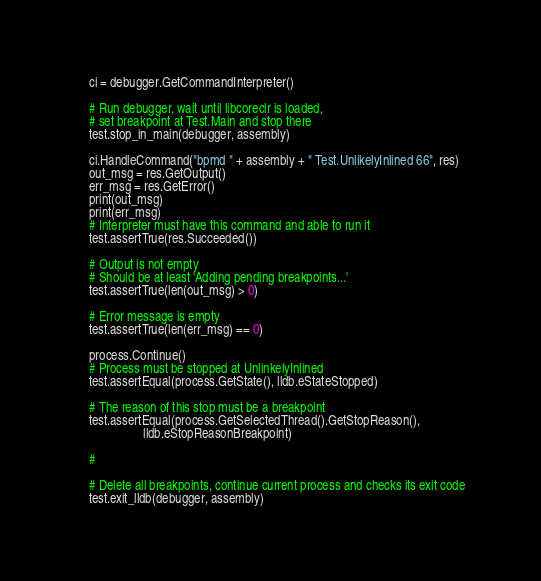<code> <loc_0><loc_0><loc_500><loc_500><_Python_>    ci = debugger.GetCommandInterpreter()

    # Run debugger, wait until libcoreclr is loaded,
    # set breakpoint at Test.Main and stop there
    test.stop_in_main(debugger, assembly)

    ci.HandleCommand("bpmd " + assembly + " Test.UnlikelyInlined 66", res)
    out_msg = res.GetOutput()
    err_msg = res.GetError()
    print(out_msg)
    print(err_msg)
    # Interpreter must have this command and able to run it
    test.assertTrue(res.Succeeded())

    # Output is not empty
    # Should be at least 'Adding pending breakpoints...'
    test.assertTrue(len(out_msg) > 0)

    # Error message is empty
    test.assertTrue(len(err_msg) == 0)

    process.Continue()
    # Process must be stopped at UnlinkelyInlined
    test.assertEqual(process.GetState(), lldb.eStateStopped)

    # The reason of this stop must be a breakpoint
    test.assertEqual(process.GetSelectedThread().GetStopReason(),
                     lldb.eStopReasonBreakpoint)

    #

    # Delete all breakpoints, continue current process and checks its exit code
    test.exit_lldb(debugger, assembly)
</code> 